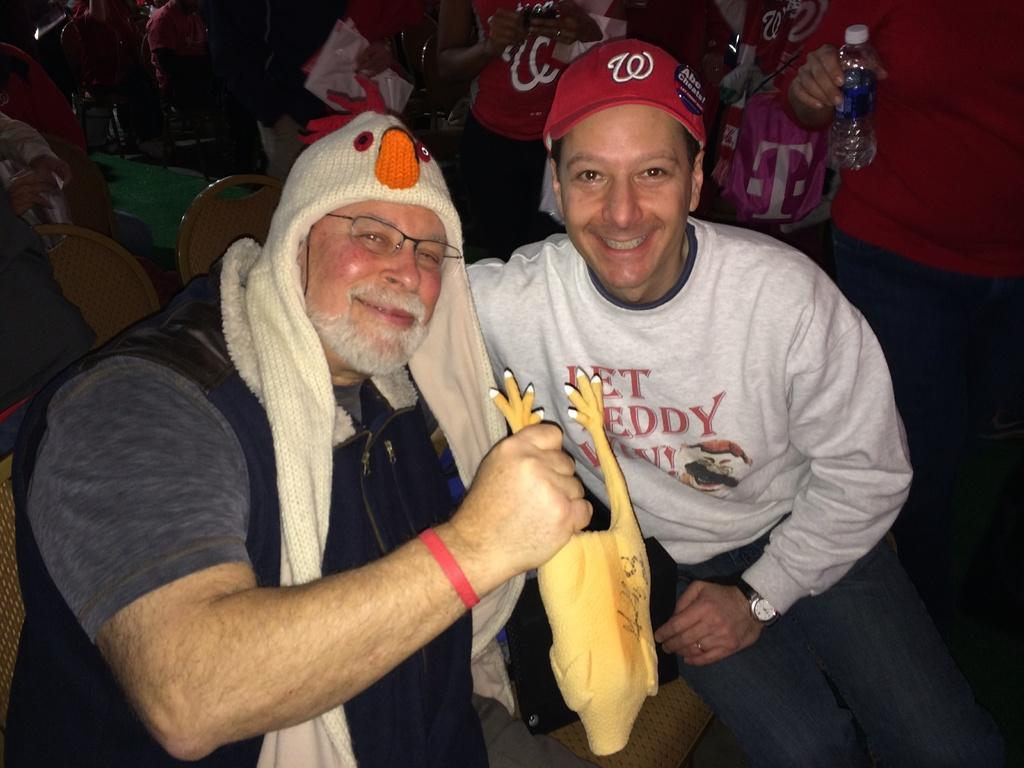<image>
Render a clear and concise summary of the photo. a man posing with another wearing a hat with the letter W on it 